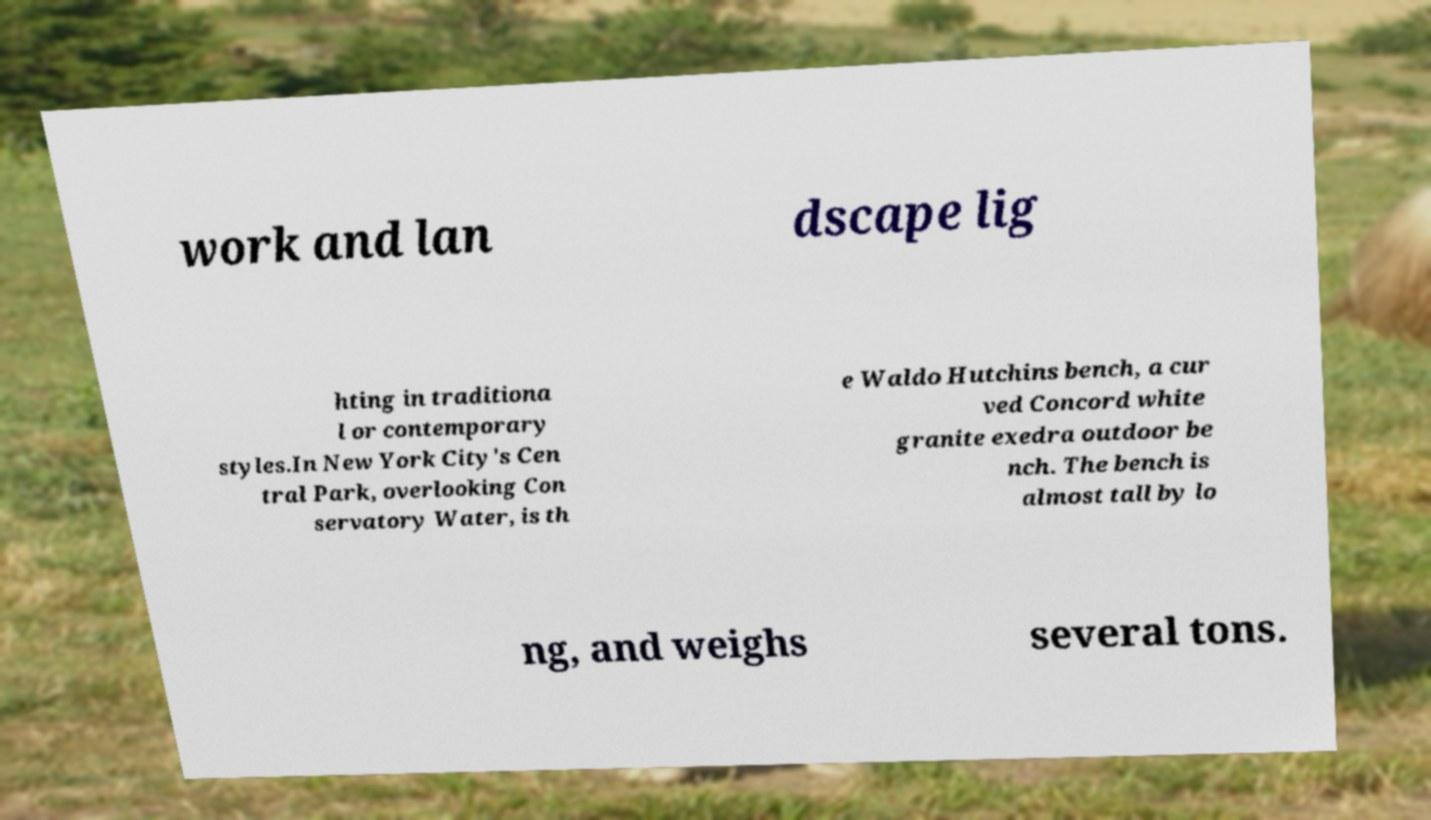What messages or text are displayed in this image? I need them in a readable, typed format. work and lan dscape lig hting in traditiona l or contemporary styles.In New York City's Cen tral Park, overlooking Con servatory Water, is th e Waldo Hutchins bench, a cur ved Concord white granite exedra outdoor be nch. The bench is almost tall by lo ng, and weighs several tons. 